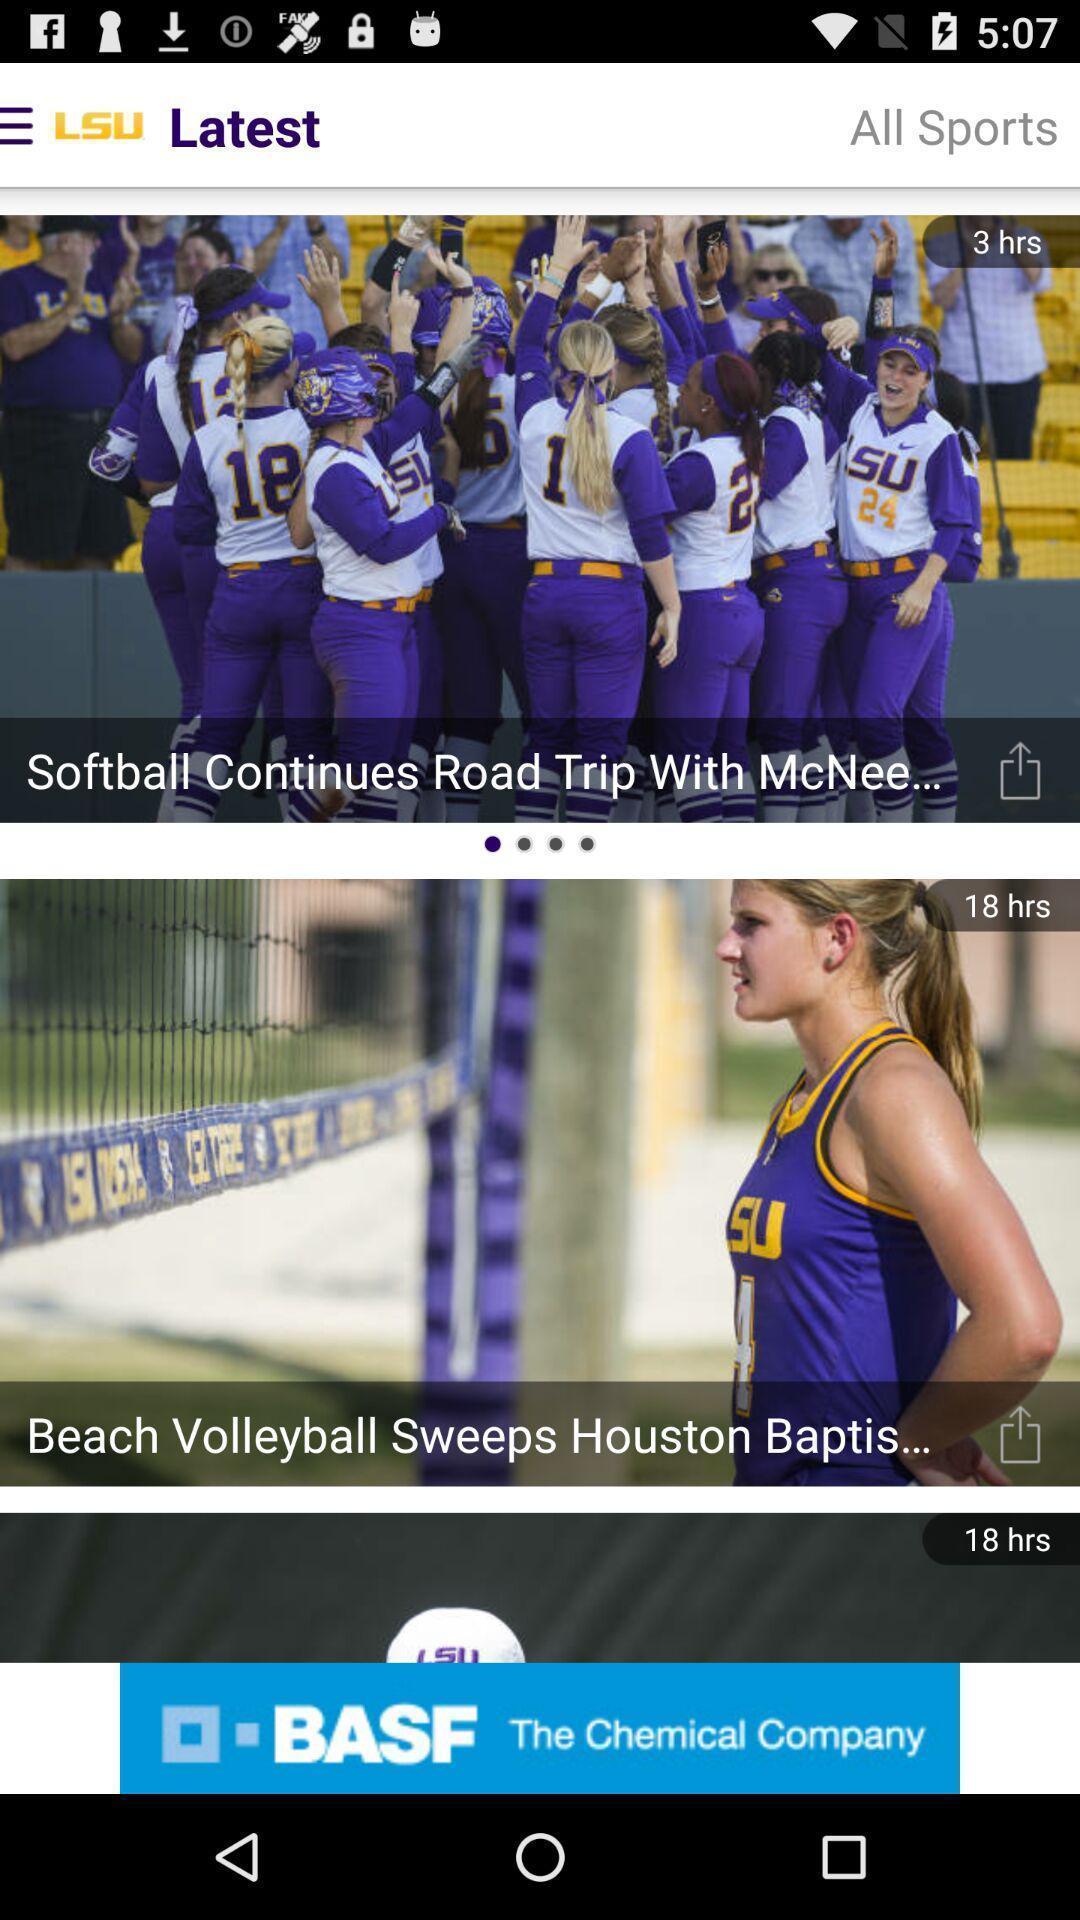What is the overall content of this screenshot? Screen page displaying news feeds in sports application. 